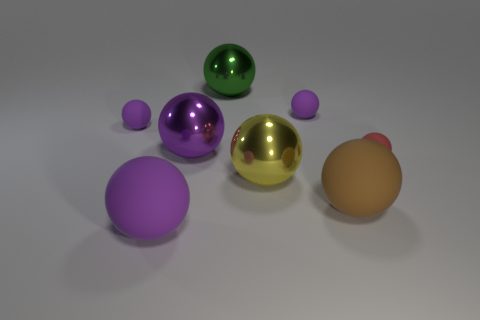The matte thing that is behind the brown rubber object and in front of the big purple shiny ball is what color?
Provide a succinct answer. Red. What is the size of the green thing that is the same shape as the big yellow thing?
Your answer should be very brief. Large. How many purple balls have the same size as the red object?
Provide a short and direct response. 2. What is the material of the red object?
Give a very brief answer. Rubber. Are there any large brown rubber objects in front of the red rubber thing?
Make the answer very short. Yes. What is the size of the purple sphere that is the same material as the yellow thing?
Make the answer very short. Large. Are there fewer shiny things behind the large yellow object than purple things that are behind the large brown object?
Provide a short and direct response. Yes. How big is the purple matte object that is in front of the big yellow metal object?
Give a very brief answer. Large. Are there any big yellow objects that have the same material as the big green sphere?
Provide a short and direct response. Yes. Are the large green thing and the big yellow object made of the same material?
Offer a terse response. Yes. 